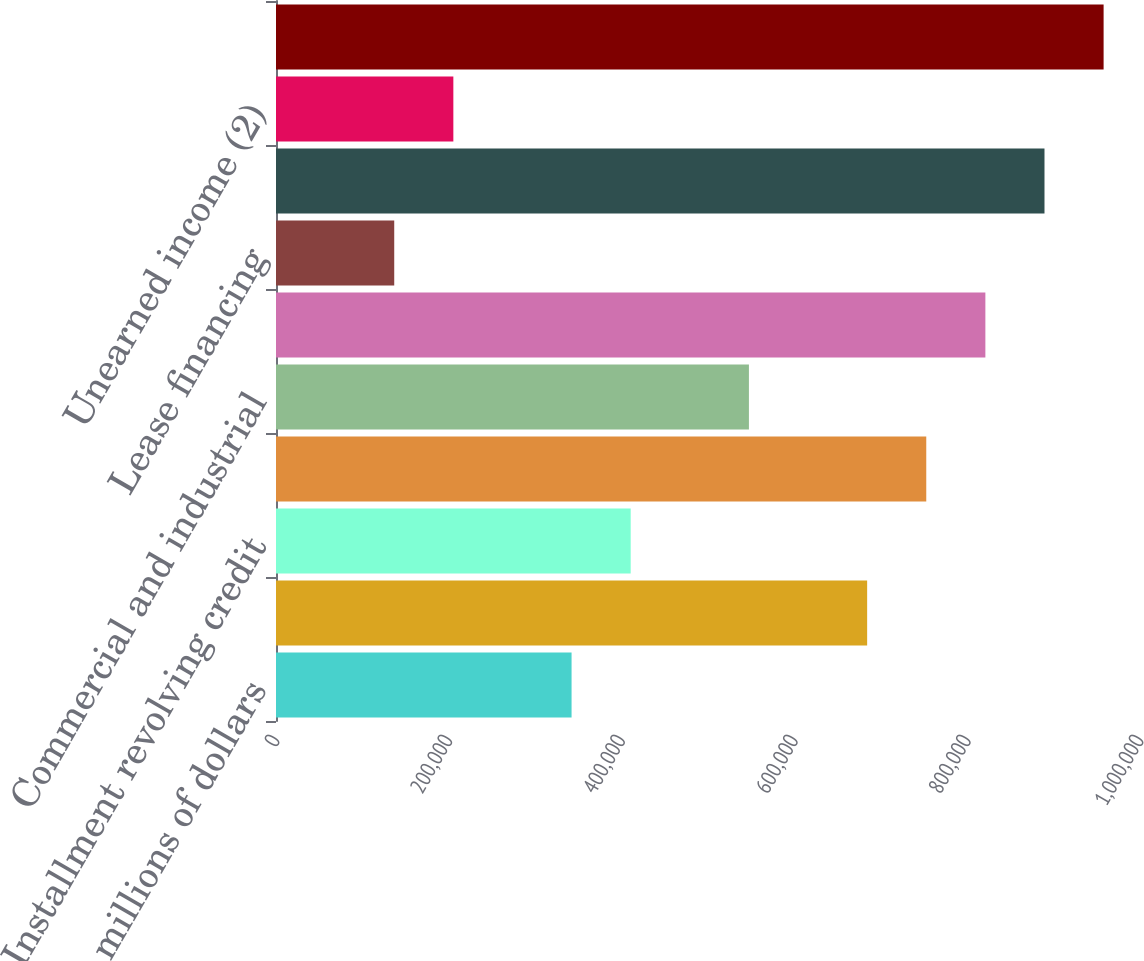Convert chart to OTSL. <chart><loc_0><loc_0><loc_500><loc_500><bar_chart><fcel>In millions of dollars<fcel>Mortgage and real estate (1)<fcel>Installment revolving credit<fcel>Cards<fcel>Commercial and industrial<fcel>Total<fcel>Lease financing<fcel>Total consumer loans<fcel>Unearned income (2)<fcel>Consumer loans net of unearned<nl><fcel>342099<fcel>684196<fcel>410518<fcel>752615<fcel>547357<fcel>821035<fcel>136841<fcel>889454<fcel>205260<fcel>957874<nl></chart> 